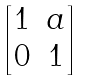<formula> <loc_0><loc_0><loc_500><loc_500>\begin{bmatrix} 1 & a \\ 0 & 1 \\ \end{bmatrix}</formula> 